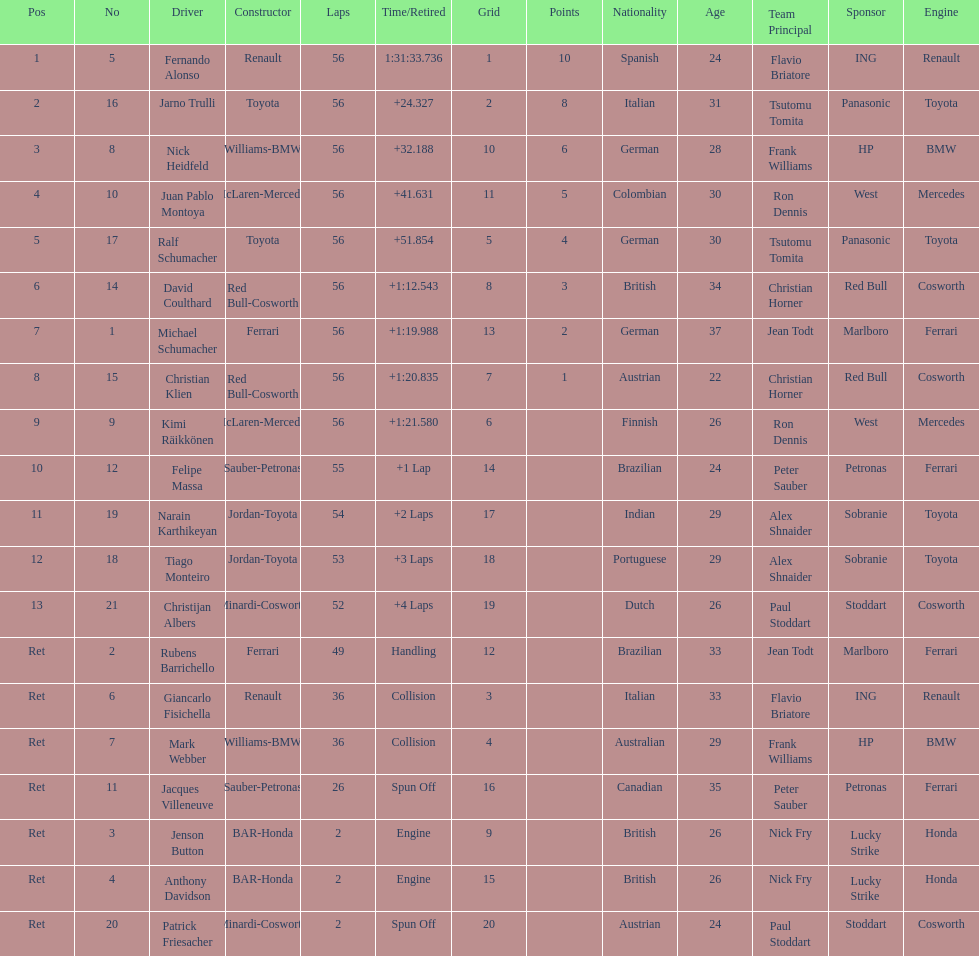Who raced during the 2005 malaysian grand prix? Fernando Alonso, Jarno Trulli, Nick Heidfeld, Juan Pablo Montoya, Ralf Schumacher, David Coulthard, Michael Schumacher, Christian Klien, Kimi Räikkönen, Felipe Massa, Narain Karthikeyan, Tiago Monteiro, Christijan Albers, Rubens Barrichello, Giancarlo Fisichella, Mark Webber, Jacques Villeneuve, Jenson Button, Anthony Davidson, Patrick Friesacher. What were their finishing times? 1:31:33.736, +24.327, +32.188, +41.631, +51.854, +1:12.543, +1:19.988, +1:20.835, +1:21.580, +1 Lap, +2 Laps, +3 Laps, +4 Laps, Handling, Collision, Collision, Spun Off, Engine, Engine, Spun Off. What was fernando alonso's finishing time? 1:31:33.736. 